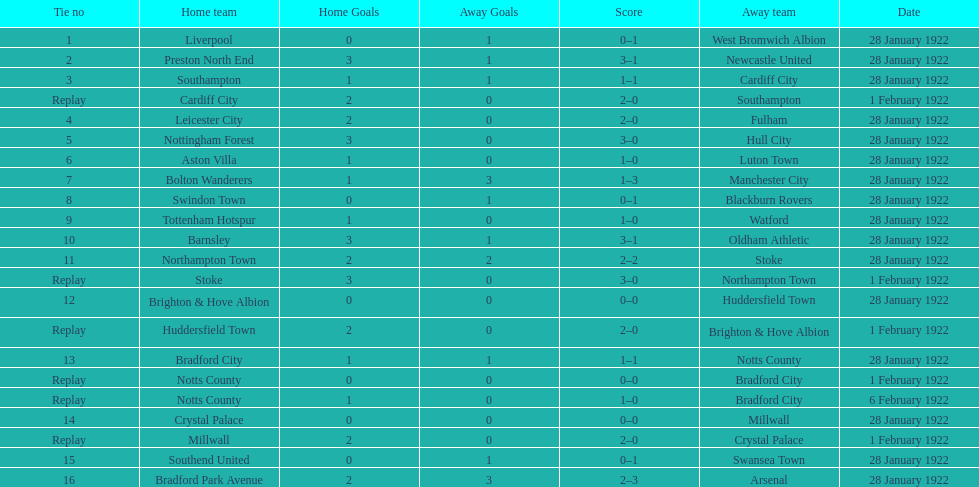Which game had a higher total number of goals scored, 1 or 16? 16. 